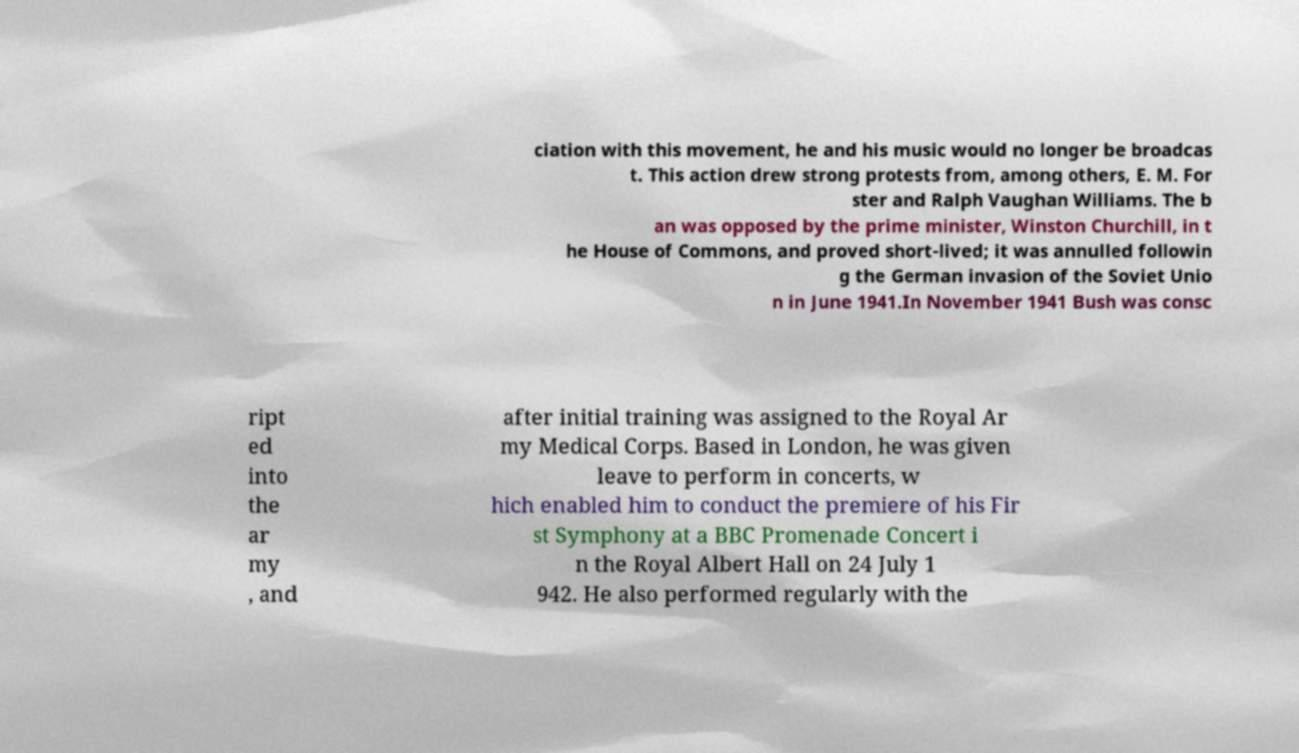Can you read and provide the text displayed in the image?This photo seems to have some interesting text. Can you extract and type it out for me? ciation with this movement, he and his music would no longer be broadcas t. This action drew strong protests from, among others, E. M. For ster and Ralph Vaughan Williams. The b an was opposed by the prime minister, Winston Churchill, in t he House of Commons, and proved short-lived; it was annulled followin g the German invasion of the Soviet Unio n in June 1941.In November 1941 Bush was consc ript ed into the ar my , and after initial training was assigned to the Royal Ar my Medical Corps. Based in London, he was given leave to perform in concerts, w hich enabled him to conduct the premiere of his Fir st Symphony at a BBC Promenade Concert i n the Royal Albert Hall on 24 July 1 942. He also performed regularly with the 